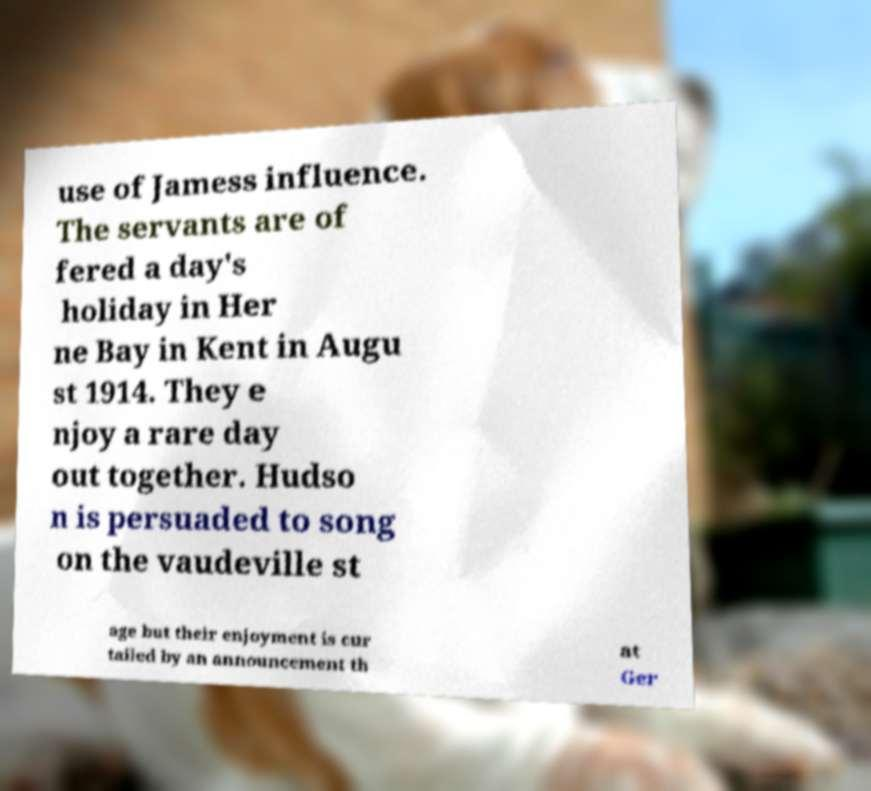What messages or text are displayed in this image? I need them in a readable, typed format. use of Jamess influence. The servants are of fered a day's holiday in Her ne Bay in Kent in Augu st 1914. They e njoy a rare day out together. Hudso n is persuaded to song on the vaudeville st age but their enjoyment is cur tailed by an announcement th at Ger 